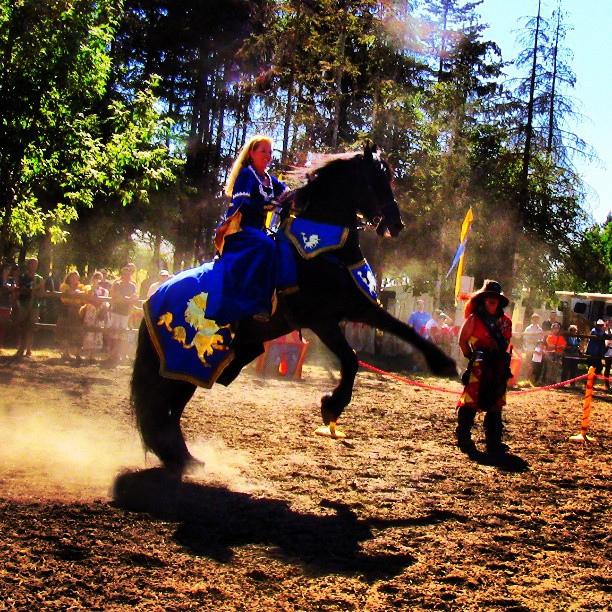Is the horse walking?
Give a very brief answer. No. What time period is the woman's costume from?
Concise answer only. Medieval. What color is the horse?
Quick response, please. Brown. 